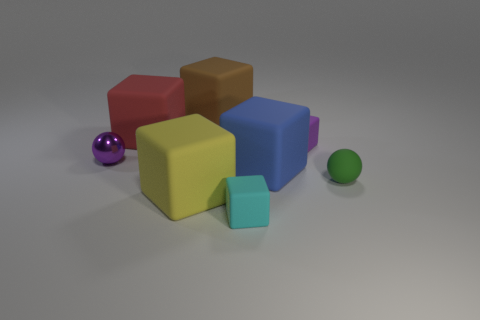Subtract all tiny matte cubes. How many cubes are left? 4 Add 2 large red metallic things. How many objects exist? 10 Subtract all red cubes. How many cubes are left? 5 Subtract 3 blocks. How many blocks are left? 3 Subtract all yellow metallic cubes. Subtract all cyan matte things. How many objects are left? 7 Add 8 tiny purple objects. How many tiny purple objects are left? 10 Add 4 large gray spheres. How many large gray spheres exist? 4 Subtract 1 blue cubes. How many objects are left? 7 Subtract all balls. How many objects are left? 6 Subtract all yellow cubes. Subtract all gray cylinders. How many cubes are left? 5 